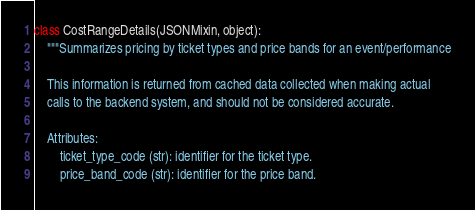Convert code to text. <code><loc_0><loc_0><loc_500><loc_500><_Python_>

class CostRangeDetails(JSONMixin, object):
    """Summarizes pricing by ticket types and price bands for an event/performance

    This information is returned from cached data collected when making actual
    calls to the backend system, and should not be considered accurate.

    Attributes:
        ticket_type_code (str): identifier for the ticket type.
        price_band_code (str): identifier for the price band.</code> 